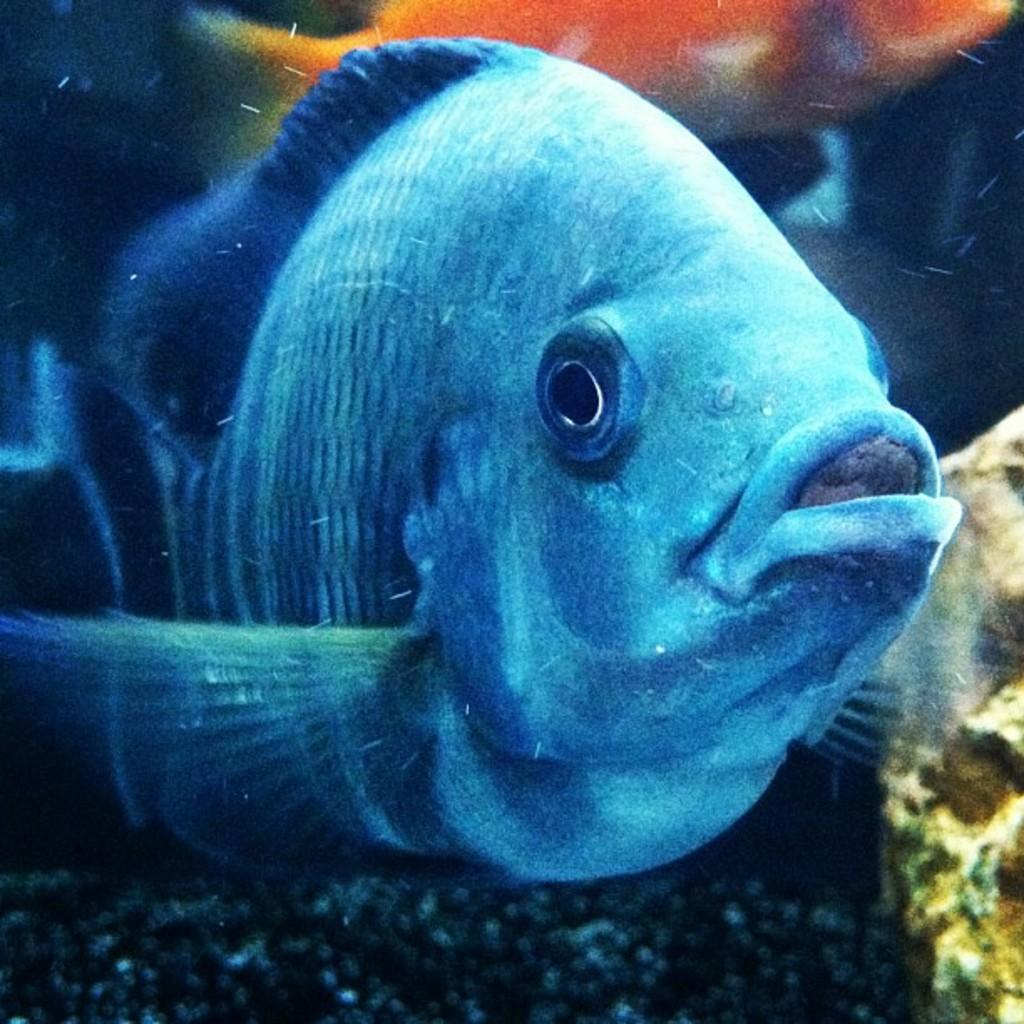Where was the image taken? The image is taken inside the water. What is the main subject of the image? There is a fish at the center of the image. What type of test can be seen being conducted in the image? There is no test being conducted in the image; it is a photograph taken underwater with a fish as the main subject. 